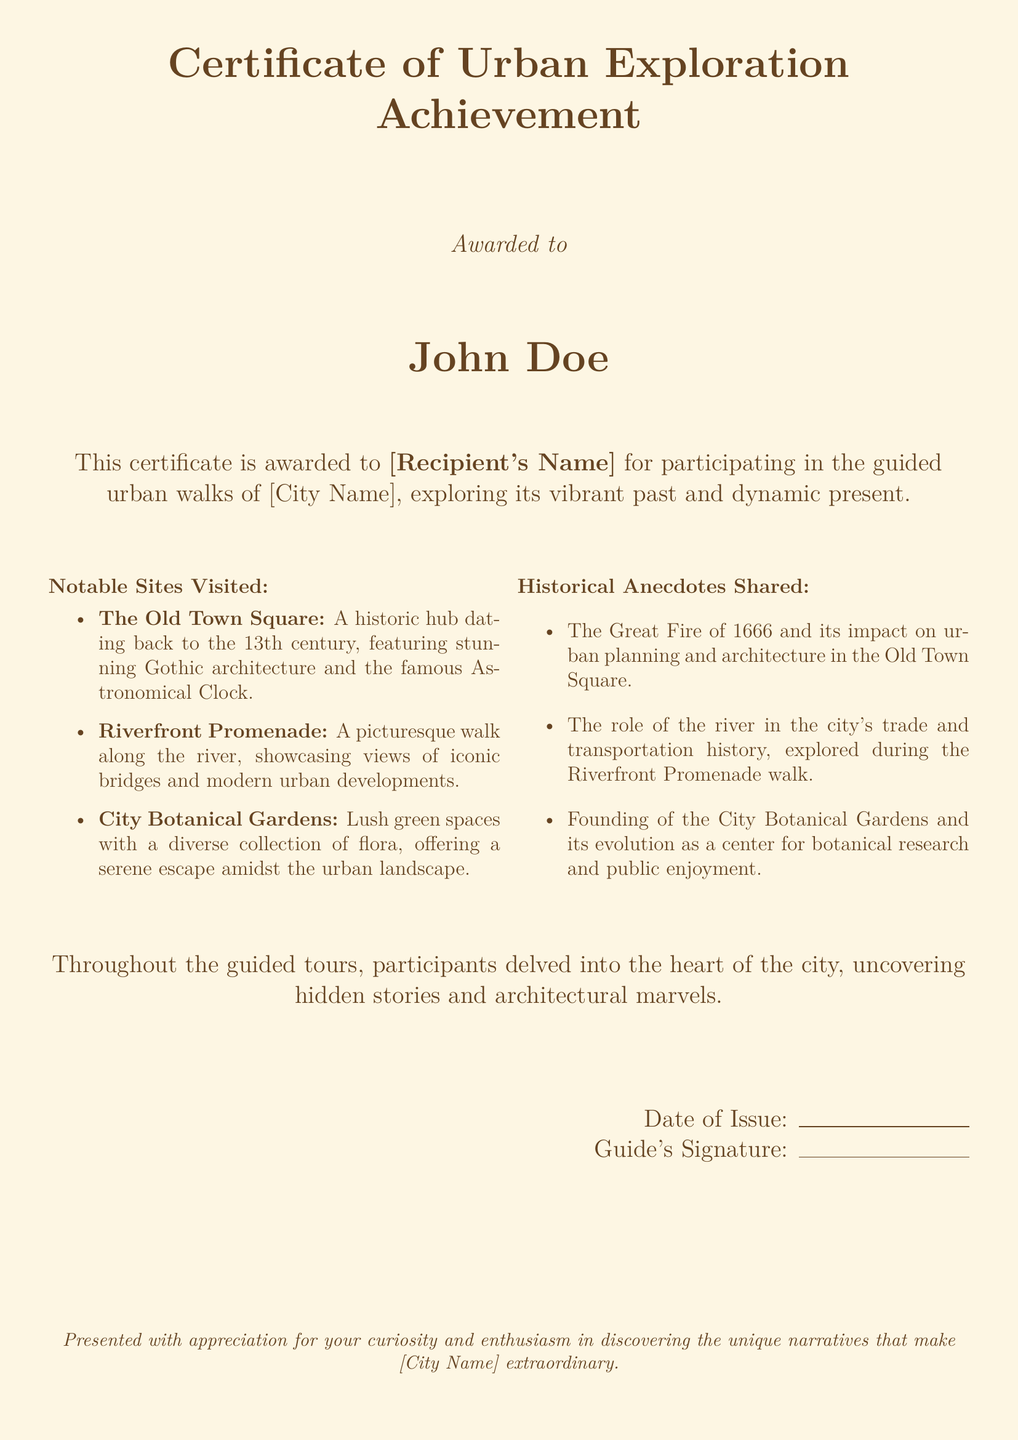What is the title of the certificate? The title of the certificate is prominently displayed at the top of the document.
Answer: Certificate of Urban Exploration Achievement Who is the certificate awarded to? The name of the recipient is mentioned in large font below the award statement.
Answer: John Doe What city is mentioned in the certificate? The certificate references the city in the award statement and appreciation message.
Answer: [City Name] What is one notable site visited? The document lists notable sites visited during the guided walks.
Answer: The Old Town Square What historical event is mentioned in the anecdotes? The document provides specific historical anecdotes related to the city's history.
Answer: The Great Fire of 1666 What does the certificate commend participants for? The appreciation statement describes what participants are recognized for.
Answer: Curiosity and enthusiasm What is the significance of the Riverfront Promenade? The document outlines the significance while mentioning it in the notable sites.
Answer: Trade and transportation history What kind of structures are highlighted in the Old Town Square? The document describes the architectural features of the notable site.
Answer: Gothic architecture What is the date of issue section for? The section allows the date to be written when the certificate is issued.
Answer: Date of Issue 